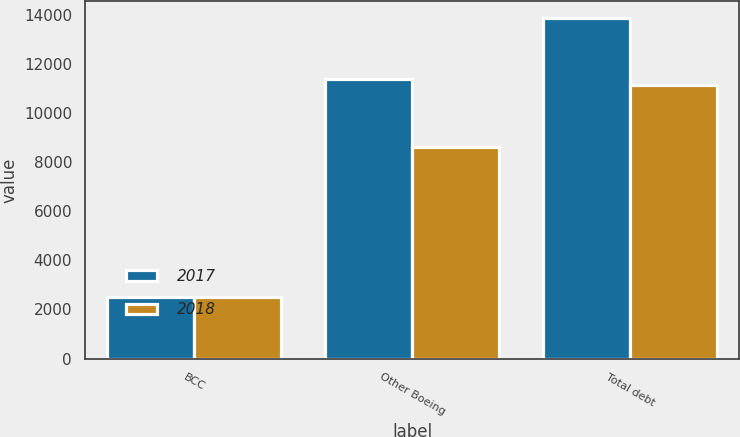Convert chart. <chart><loc_0><loc_0><loc_500><loc_500><stacked_bar_chart><ecel><fcel>BCC<fcel>Other Boeing<fcel>Total debt<nl><fcel>2017<fcel>2487<fcel>11360<fcel>13847<nl><fcel>2018<fcel>2523<fcel>8594<fcel>11117<nl></chart> 